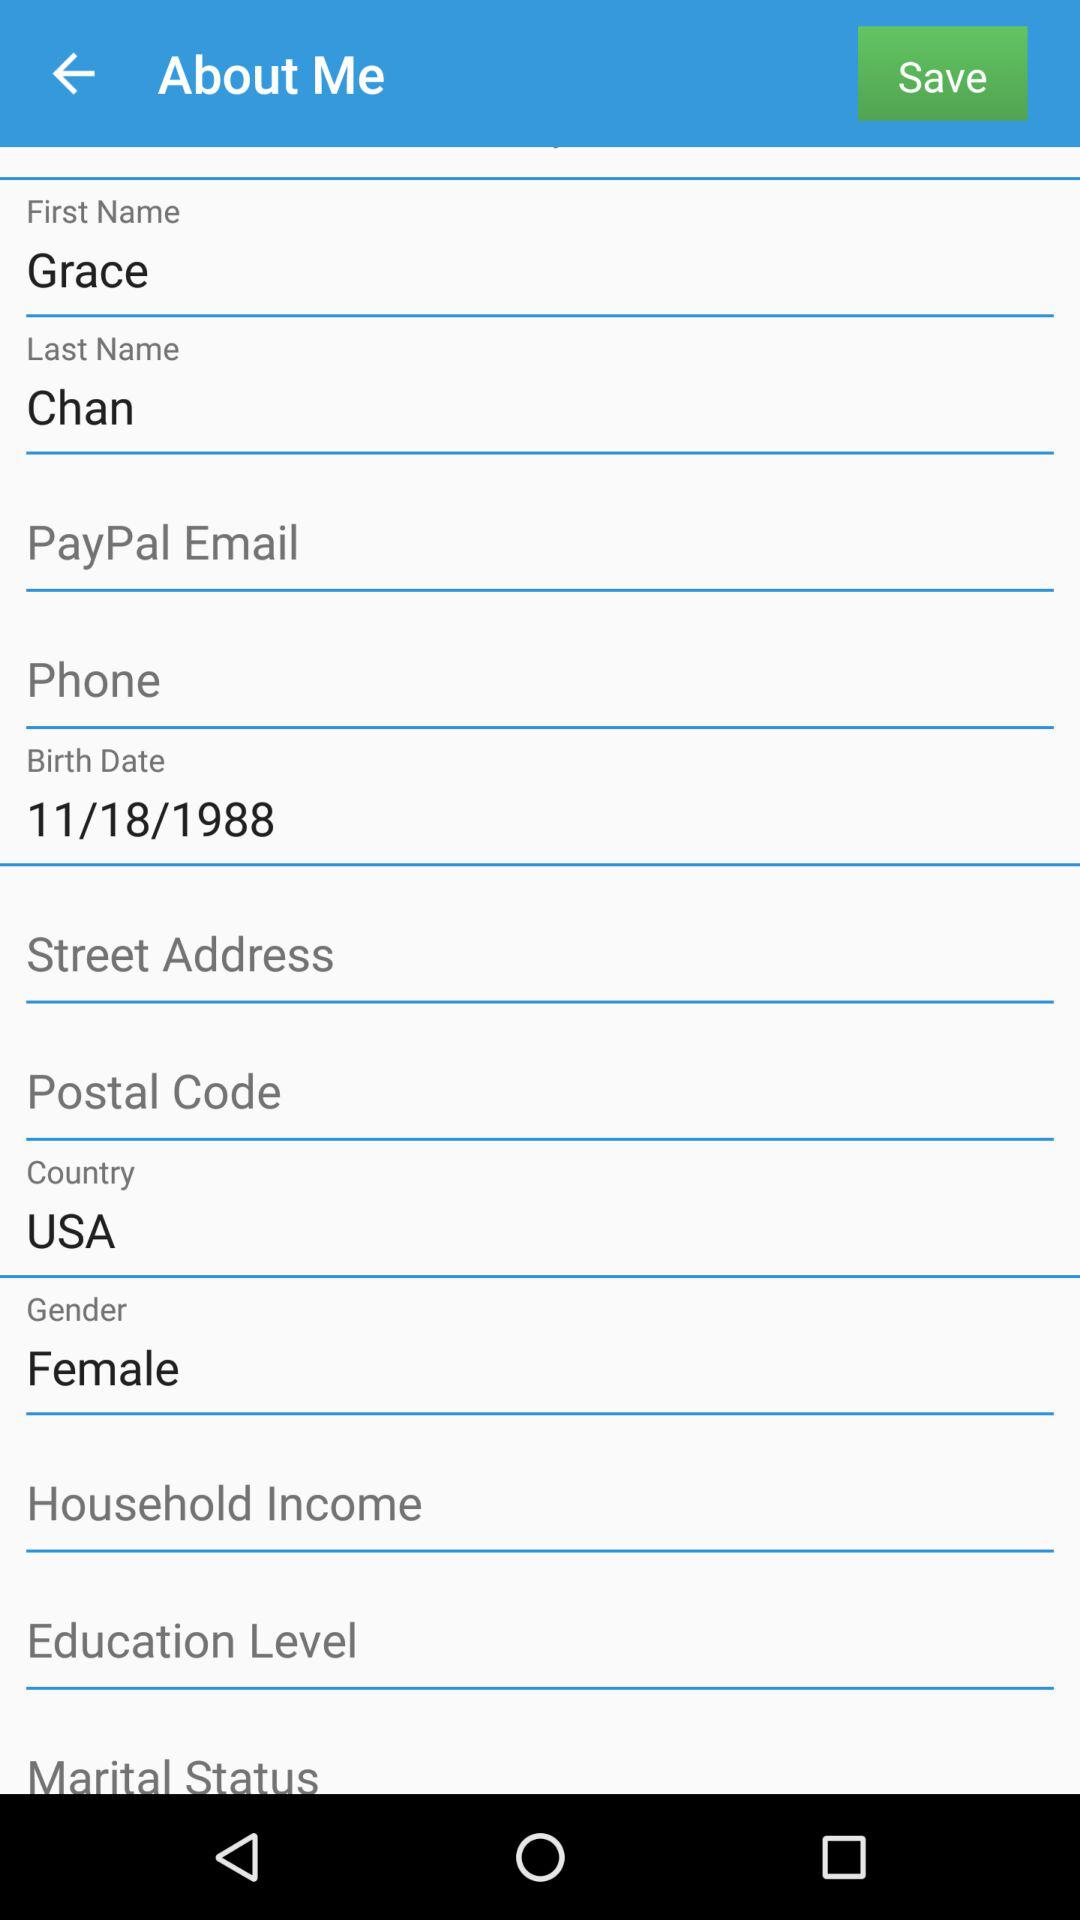What is the first name? The first name is Grace. 